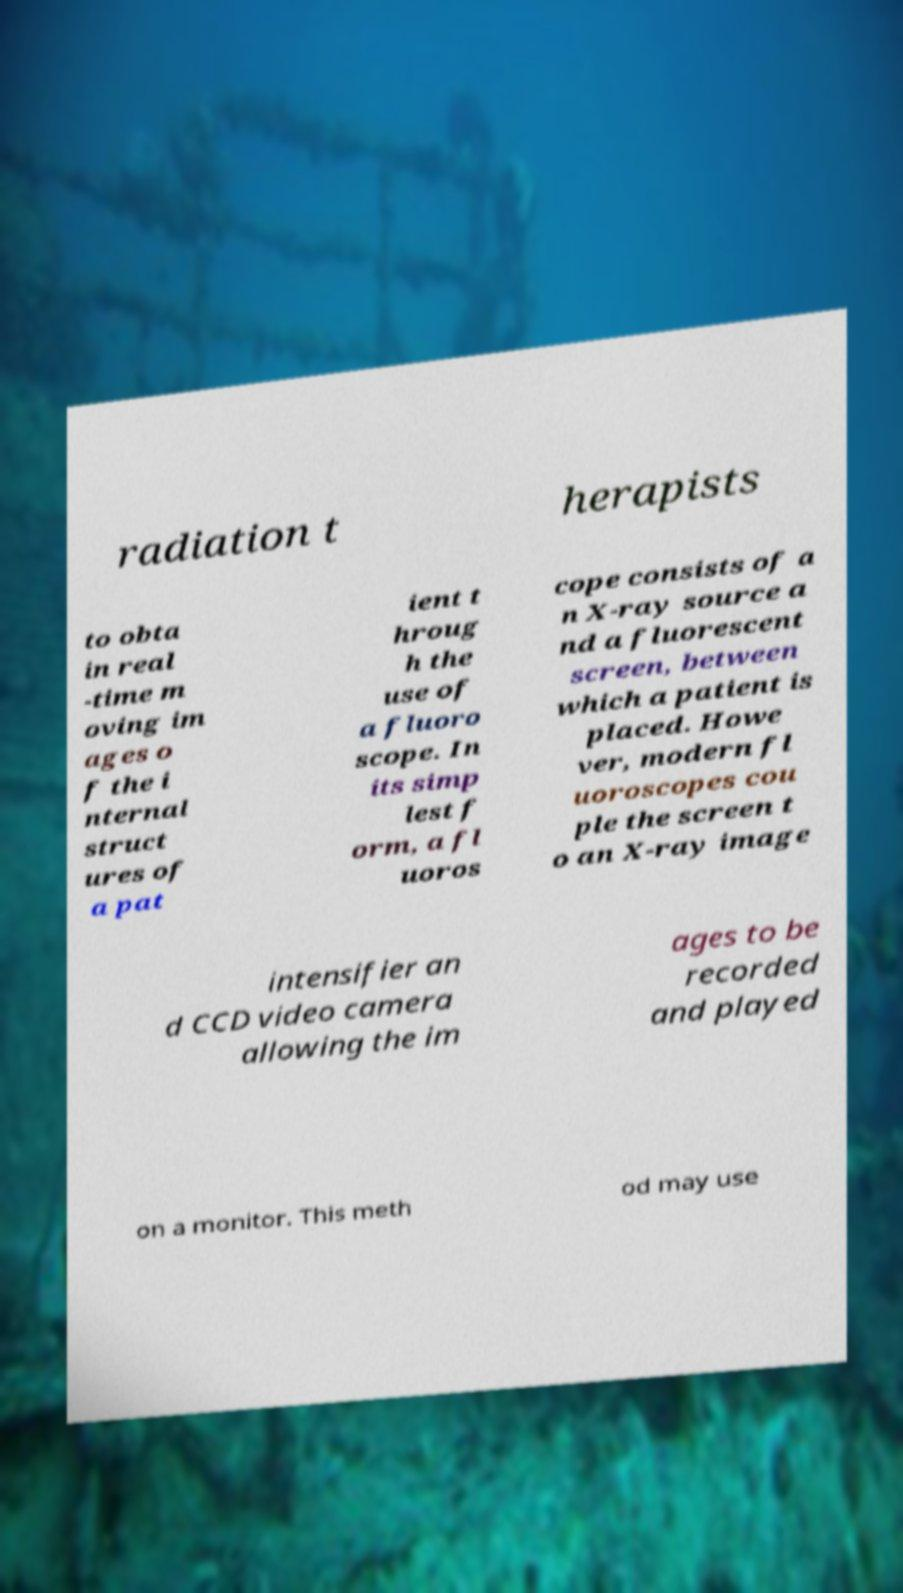Could you extract and type out the text from this image? radiation t herapists to obta in real -time m oving im ages o f the i nternal struct ures of a pat ient t hroug h the use of a fluoro scope. In its simp lest f orm, a fl uoros cope consists of a n X-ray source a nd a fluorescent screen, between which a patient is placed. Howe ver, modern fl uoroscopes cou ple the screen t o an X-ray image intensifier an d CCD video camera allowing the im ages to be recorded and played on a monitor. This meth od may use 